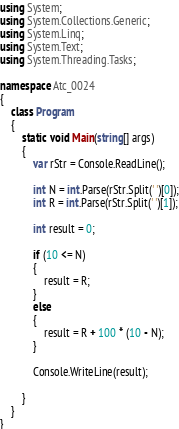<code> <loc_0><loc_0><loc_500><loc_500><_C#_>using System;
using System.Collections.Generic;
using System.Linq;
using System.Text;
using System.Threading.Tasks;

namespace Atc_0024
{
    class Program
    {
        static void Main(string[] args)
        {
            var rStr = Console.ReadLine();

            int N = int.Parse(rStr.Split(' ')[0]);
            int R = int.Parse(rStr.Split(' ')[1]);

            int result = 0;

            if (10 <= N)
            {
                result = R;
            }
            else
            {
                result = R + 100 * (10 - N);
            }

            Console.WriteLine(result);

        }
    }
}
</code> 